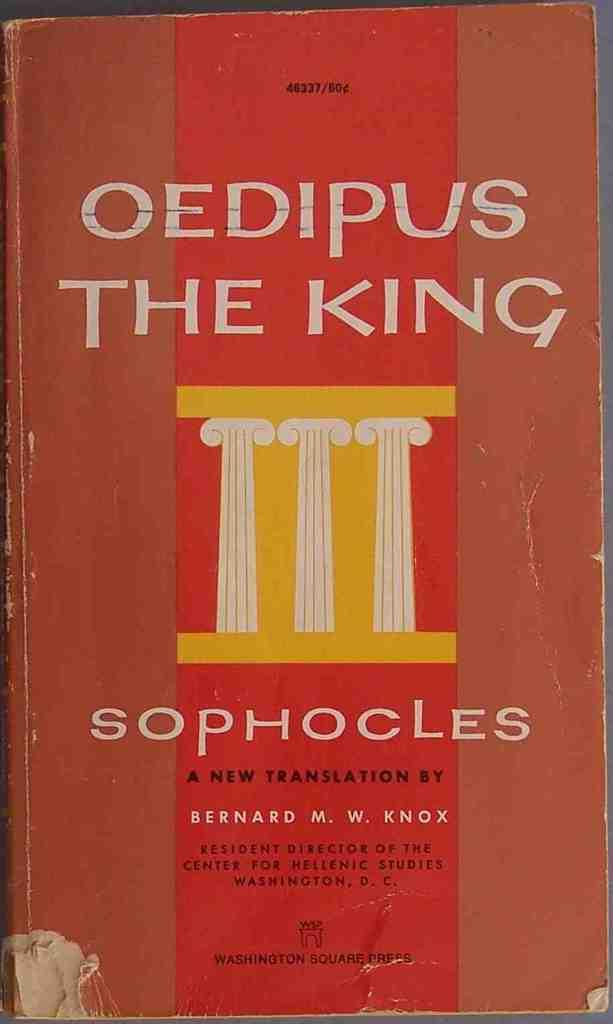Provide a one-sentence caption for the provided image. The cover of the book "Oedipus The King" translated by Bernard M. W. Knox. 